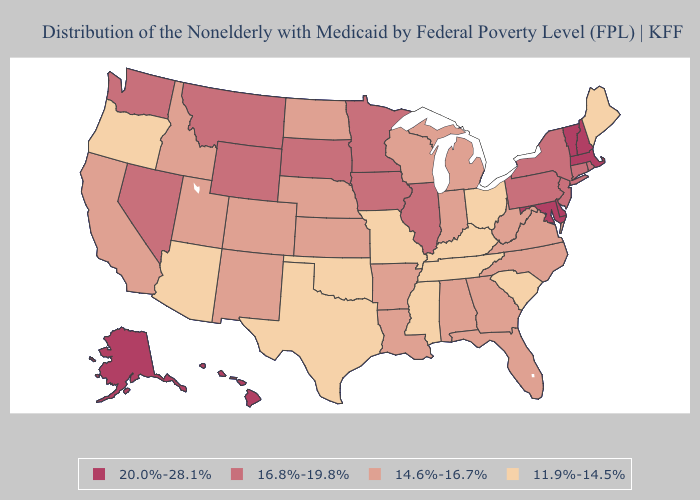How many symbols are there in the legend?
Write a very short answer. 4. Does Michigan have the lowest value in the MidWest?
Quick response, please. No. What is the value of Mississippi?
Be succinct. 11.9%-14.5%. Which states have the lowest value in the South?
Short answer required. Kentucky, Mississippi, Oklahoma, South Carolina, Tennessee, Texas. Among the states that border West Virginia , does Ohio have the highest value?
Give a very brief answer. No. What is the lowest value in the South?
Keep it brief. 11.9%-14.5%. What is the highest value in states that border Massachusetts?
Quick response, please. 20.0%-28.1%. Does Colorado have a higher value than Mississippi?
Short answer required. Yes. What is the value of Pennsylvania?
Short answer required. 16.8%-19.8%. Does the map have missing data?
Keep it brief. No. Which states hav the highest value in the MidWest?
Answer briefly. Illinois, Iowa, Minnesota, South Dakota. Name the states that have a value in the range 20.0%-28.1%?
Give a very brief answer. Alaska, Delaware, Hawaii, Maryland, Massachusetts, New Hampshire, Vermont. Does Arizona have the lowest value in the USA?
Short answer required. Yes. What is the value of Hawaii?
Concise answer only. 20.0%-28.1%. Name the states that have a value in the range 14.6%-16.7%?
Be succinct. Alabama, Arkansas, California, Colorado, Florida, Georgia, Idaho, Indiana, Kansas, Louisiana, Michigan, Nebraska, New Mexico, North Carolina, North Dakota, Utah, Virginia, West Virginia, Wisconsin. 